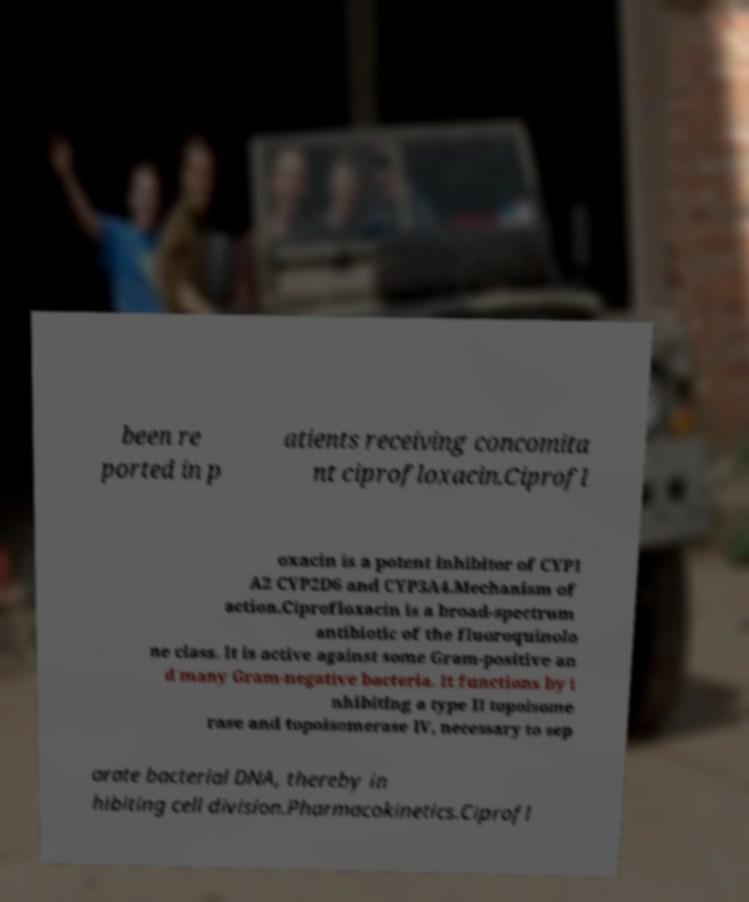What messages or text are displayed in this image? I need them in a readable, typed format. been re ported in p atients receiving concomita nt ciprofloxacin.Ciprofl oxacin is a potent inhibitor of CYP1 A2 CYP2D6 and CYP3A4.Mechanism of action.Ciprofloxacin is a broad-spectrum antibiotic of the fluoroquinolo ne class. It is active against some Gram-positive an d many Gram-negative bacteria. It functions by i nhibiting a type II topoisome rase and topoisomerase IV, necessary to sep arate bacterial DNA, thereby in hibiting cell division.Pharmacokinetics.Ciprofl 